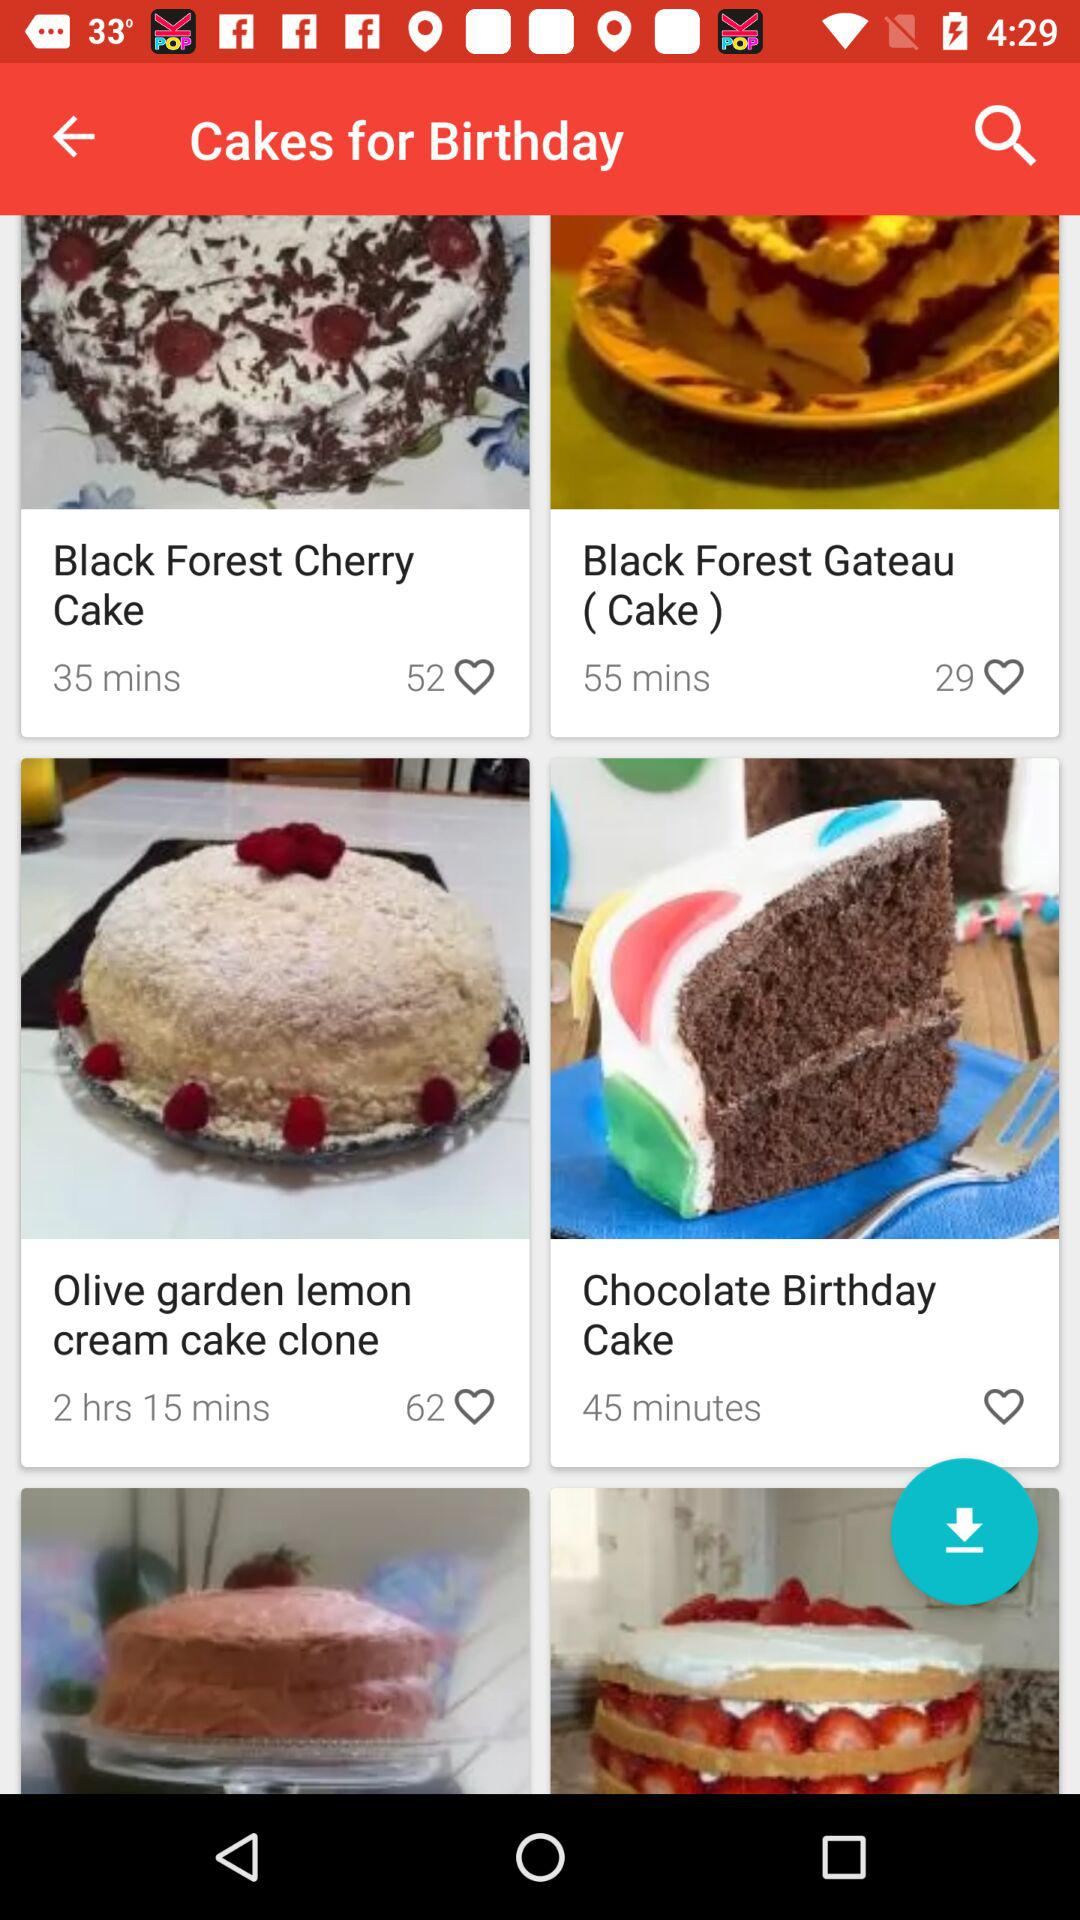How much time is required to make "Black Forest Cherry Cake"? The required time to make "Black Forest Cherry Cake" is 35 minutes. 